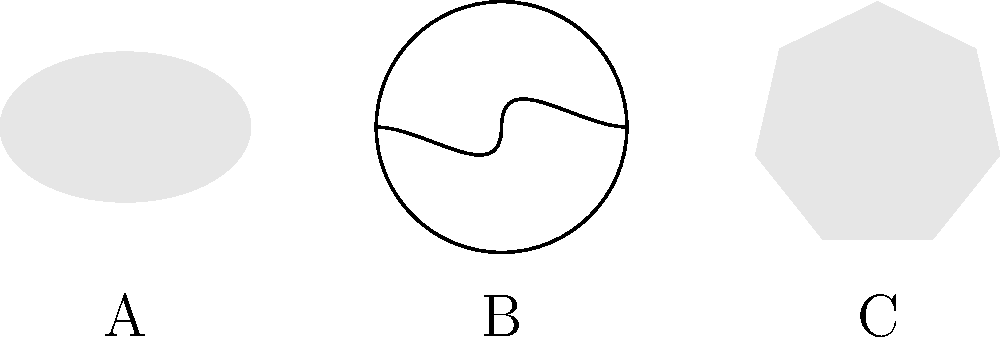In your investigation of the school's test-centric approach, you decide to create a sample astronomy question to assess students' knowledge of galaxy types. Which of the basic shapes (A, B, or C) best represents a spiral galaxy? To answer this question, we need to understand the basic characteristics of the three main types of galaxies and match them to the shapes presented:

1. Elliptical galaxies (A):
   - Smooth, featureless appearance
   - Elliptical or spheroidal shape
   - No visible structure or arms

2. Spiral galaxies (B):
   - Distinct spiral arms extending from a central bulge
   - Often have a disk-like structure
   - Visible rotating pattern

3. Irregular galaxies (C):
   - No definite shape or structure
   - Often appear asymmetrical or chaotic

Looking at the shapes provided:
- Shape A is a smooth ellipse, representing an elliptical galaxy.
- Shape B shows a circular outline with two curved arms extending from the center, clearly representing a spiral galaxy.
- Shape C has an irregular, asymmetrical shape, representing an irregular galaxy.

Therefore, the shape that best represents a spiral galaxy is B.
Answer: B 